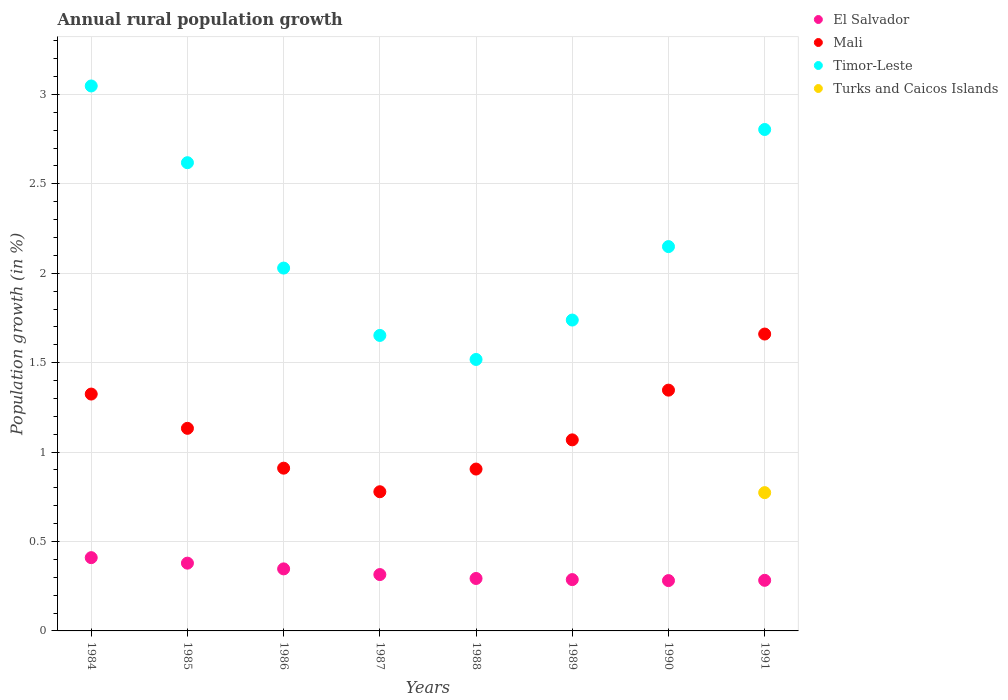Is the number of dotlines equal to the number of legend labels?
Your response must be concise. No. What is the percentage of rural population growth in El Salvador in 1989?
Your answer should be compact. 0.29. Across all years, what is the maximum percentage of rural population growth in El Salvador?
Offer a very short reply. 0.41. Across all years, what is the minimum percentage of rural population growth in Timor-Leste?
Your response must be concise. 1.52. In which year was the percentage of rural population growth in Timor-Leste maximum?
Provide a short and direct response. 1984. What is the total percentage of rural population growth in El Salvador in the graph?
Offer a terse response. 2.6. What is the difference between the percentage of rural population growth in El Salvador in 1987 and that in 1990?
Offer a very short reply. 0.03. What is the difference between the percentage of rural population growth in Mali in 1985 and the percentage of rural population growth in Turks and Caicos Islands in 1986?
Your response must be concise. 1.13. What is the average percentage of rural population growth in Mali per year?
Offer a terse response. 1.14. In the year 1984, what is the difference between the percentage of rural population growth in Mali and percentage of rural population growth in Timor-Leste?
Your answer should be very brief. -1.72. In how many years, is the percentage of rural population growth in Timor-Leste greater than 0.7 %?
Offer a very short reply. 8. What is the ratio of the percentage of rural population growth in El Salvador in 1984 to that in 1987?
Provide a short and direct response. 1.3. What is the difference between the highest and the second highest percentage of rural population growth in Timor-Leste?
Ensure brevity in your answer.  0.24. What is the difference between the highest and the lowest percentage of rural population growth in Turks and Caicos Islands?
Your response must be concise. 0.77. Is it the case that in every year, the sum of the percentage of rural population growth in Mali and percentage of rural population growth in Timor-Leste  is greater than the sum of percentage of rural population growth in El Salvador and percentage of rural population growth in Turks and Caicos Islands?
Provide a short and direct response. No. Is the percentage of rural population growth in Timor-Leste strictly greater than the percentage of rural population growth in Mali over the years?
Ensure brevity in your answer.  Yes. Is the percentage of rural population growth in Turks and Caicos Islands strictly less than the percentage of rural population growth in Mali over the years?
Your response must be concise. Yes. How many years are there in the graph?
Offer a terse response. 8. How many legend labels are there?
Ensure brevity in your answer.  4. How are the legend labels stacked?
Keep it short and to the point. Vertical. What is the title of the graph?
Your response must be concise. Annual rural population growth. What is the label or title of the Y-axis?
Keep it short and to the point. Population growth (in %). What is the Population growth (in %) in El Salvador in 1984?
Give a very brief answer. 0.41. What is the Population growth (in %) in Mali in 1984?
Offer a terse response. 1.32. What is the Population growth (in %) of Timor-Leste in 1984?
Offer a very short reply. 3.05. What is the Population growth (in %) in El Salvador in 1985?
Provide a short and direct response. 0.38. What is the Population growth (in %) in Mali in 1985?
Give a very brief answer. 1.13. What is the Population growth (in %) in Timor-Leste in 1985?
Give a very brief answer. 2.62. What is the Population growth (in %) of Turks and Caicos Islands in 1985?
Your response must be concise. 0. What is the Population growth (in %) in El Salvador in 1986?
Keep it short and to the point. 0.35. What is the Population growth (in %) in Mali in 1986?
Keep it short and to the point. 0.91. What is the Population growth (in %) of Timor-Leste in 1986?
Ensure brevity in your answer.  2.03. What is the Population growth (in %) of Turks and Caicos Islands in 1986?
Your response must be concise. 0. What is the Population growth (in %) of El Salvador in 1987?
Your answer should be compact. 0.32. What is the Population growth (in %) of Mali in 1987?
Make the answer very short. 0.78. What is the Population growth (in %) in Timor-Leste in 1987?
Offer a very short reply. 1.65. What is the Population growth (in %) in Turks and Caicos Islands in 1987?
Your response must be concise. 0. What is the Population growth (in %) of El Salvador in 1988?
Make the answer very short. 0.29. What is the Population growth (in %) in Mali in 1988?
Ensure brevity in your answer.  0.91. What is the Population growth (in %) of Timor-Leste in 1988?
Your answer should be compact. 1.52. What is the Population growth (in %) in El Salvador in 1989?
Keep it short and to the point. 0.29. What is the Population growth (in %) of Mali in 1989?
Make the answer very short. 1.07. What is the Population growth (in %) in Timor-Leste in 1989?
Make the answer very short. 1.74. What is the Population growth (in %) of El Salvador in 1990?
Your response must be concise. 0.28. What is the Population growth (in %) in Mali in 1990?
Your answer should be compact. 1.35. What is the Population growth (in %) of Timor-Leste in 1990?
Provide a short and direct response. 2.15. What is the Population growth (in %) of Turks and Caicos Islands in 1990?
Your answer should be very brief. 0. What is the Population growth (in %) in El Salvador in 1991?
Keep it short and to the point. 0.28. What is the Population growth (in %) in Mali in 1991?
Provide a short and direct response. 1.66. What is the Population growth (in %) of Timor-Leste in 1991?
Provide a succinct answer. 2.8. What is the Population growth (in %) in Turks and Caicos Islands in 1991?
Ensure brevity in your answer.  0.77. Across all years, what is the maximum Population growth (in %) in El Salvador?
Provide a succinct answer. 0.41. Across all years, what is the maximum Population growth (in %) of Mali?
Provide a succinct answer. 1.66. Across all years, what is the maximum Population growth (in %) in Timor-Leste?
Ensure brevity in your answer.  3.05. Across all years, what is the maximum Population growth (in %) of Turks and Caicos Islands?
Ensure brevity in your answer.  0.77. Across all years, what is the minimum Population growth (in %) in El Salvador?
Offer a very short reply. 0.28. Across all years, what is the minimum Population growth (in %) in Mali?
Make the answer very short. 0.78. Across all years, what is the minimum Population growth (in %) of Timor-Leste?
Make the answer very short. 1.52. Across all years, what is the minimum Population growth (in %) in Turks and Caicos Islands?
Your response must be concise. 0. What is the total Population growth (in %) in El Salvador in the graph?
Provide a succinct answer. 2.6. What is the total Population growth (in %) of Mali in the graph?
Your answer should be very brief. 9.13. What is the total Population growth (in %) of Timor-Leste in the graph?
Provide a short and direct response. 17.56. What is the total Population growth (in %) of Turks and Caicos Islands in the graph?
Offer a very short reply. 0.77. What is the difference between the Population growth (in %) in El Salvador in 1984 and that in 1985?
Offer a very short reply. 0.03. What is the difference between the Population growth (in %) of Mali in 1984 and that in 1985?
Give a very brief answer. 0.19. What is the difference between the Population growth (in %) in Timor-Leste in 1984 and that in 1985?
Make the answer very short. 0.43. What is the difference between the Population growth (in %) in El Salvador in 1984 and that in 1986?
Your answer should be very brief. 0.06. What is the difference between the Population growth (in %) in Mali in 1984 and that in 1986?
Provide a succinct answer. 0.41. What is the difference between the Population growth (in %) of Timor-Leste in 1984 and that in 1986?
Give a very brief answer. 1.02. What is the difference between the Population growth (in %) in El Salvador in 1984 and that in 1987?
Provide a short and direct response. 0.09. What is the difference between the Population growth (in %) of Mali in 1984 and that in 1987?
Your response must be concise. 0.55. What is the difference between the Population growth (in %) of Timor-Leste in 1984 and that in 1987?
Keep it short and to the point. 1.4. What is the difference between the Population growth (in %) of El Salvador in 1984 and that in 1988?
Make the answer very short. 0.12. What is the difference between the Population growth (in %) in Mali in 1984 and that in 1988?
Your response must be concise. 0.42. What is the difference between the Population growth (in %) in Timor-Leste in 1984 and that in 1988?
Your response must be concise. 1.53. What is the difference between the Population growth (in %) in El Salvador in 1984 and that in 1989?
Ensure brevity in your answer.  0.12. What is the difference between the Population growth (in %) in Mali in 1984 and that in 1989?
Offer a very short reply. 0.26. What is the difference between the Population growth (in %) in Timor-Leste in 1984 and that in 1989?
Offer a terse response. 1.31. What is the difference between the Population growth (in %) in El Salvador in 1984 and that in 1990?
Your answer should be very brief. 0.13. What is the difference between the Population growth (in %) in Mali in 1984 and that in 1990?
Give a very brief answer. -0.02. What is the difference between the Population growth (in %) of Timor-Leste in 1984 and that in 1990?
Keep it short and to the point. 0.9. What is the difference between the Population growth (in %) of El Salvador in 1984 and that in 1991?
Provide a succinct answer. 0.13. What is the difference between the Population growth (in %) in Mali in 1984 and that in 1991?
Your response must be concise. -0.34. What is the difference between the Population growth (in %) in Timor-Leste in 1984 and that in 1991?
Provide a succinct answer. 0.24. What is the difference between the Population growth (in %) of El Salvador in 1985 and that in 1986?
Provide a succinct answer. 0.03. What is the difference between the Population growth (in %) in Mali in 1985 and that in 1986?
Ensure brevity in your answer.  0.22. What is the difference between the Population growth (in %) of Timor-Leste in 1985 and that in 1986?
Ensure brevity in your answer.  0.59. What is the difference between the Population growth (in %) in El Salvador in 1985 and that in 1987?
Ensure brevity in your answer.  0.06. What is the difference between the Population growth (in %) of Mali in 1985 and that in 1987?
Offer a terse response. 0.35. What is the difference between the Population growth (in %) in Timor-Leste in 1985 and that in 1987?
Provide a succinct answer. 0.97. What is the difference between the Population growth (in %) in El Salvador in 1985 and that in 1988?
Your response must be concise. 0.09. What is the difference between the Population growth (in %) of Mali in 1985 and that in 1988?
Ensure brevity in your answer.  0.23. What is the difference between the Population growth (in %) of Timor-Leste in 1985 and that in 1988?
Keep it short and to the point. 1.1. What is the difference between the Population growth (in %) in El Salvador in 1985 and that in 1989?
Give a very brief answer. 0.09. What is the difference between the Population growth (in %) of Mali in 1985 and that in 1989?
Offer a very short reply. 0.06. What is the difference between the Population growth (in %) in Timor-Leste in 1985 and that in 1989?
Keep it short and to the point. 0.88. What is the difference between the Population growth (in %) in El Salvador in 1985 and that in 1990?
Offer a very short reply. 0.1. What is the difference between the Population growth (in %) in Mali in 1985 and that in 1990?
Provide a short and direct response. -0.21. What is the difference between the Population growth (in %) in Timor-Leste in 1985 and that in 1990?
Offer a very short reply. 0.47. What is the difference between the Population growth (in %) of El Salvador in 1985 and that in 1991?
Ensure brevity in your answer.  0.1. What is the difference between the Population growth (in %) of Mali in 1985 and that in 1991?
Provide a short and direct response. -0.53. What is the difference between the Population growth (in %) of Timor-Leste in 1985 and that in 1991?
Offer a very short reply. -0.19. What is the difference between the Population growth (in %) of El Salvador in 1986 and that in 1987?
Your answer should be compact. 0.03. What is the difference between the Population growth (in %) of Mali in 1986 and that in 1987?
Your answer should be compact. 0.13. What is the difference between the Population growth (in %) in Timor-Leste in 1986 and that in 1987?
Your response must be concise. 0.38. What is the difference between the Population growth (in %) in El Salvador in 1986 and that in 1988?
Offer a very short reply. 0.05. What is the difference between the Population growth (in %) in Mali in 1986 and that in 1988?
Ensure brevity in your answer.  0.01. What is the difference between the Population growth (in %) in Timor-Leste in 1986 and that in 1988?
Make the answer very short. 0.51. What is the difference between the Population growth (in %) in El Salvador in 1986 and that in 1989?
Give a very brief answer. 0.06. What is the difference between the Population growth (in %) in Mali in 1986 and that in 1989?
Your answer should be compact. -0.16. What is the difference between the Population growth (in %) of Timor-Leste in 1986 and that in 1989?
Provide a succinct answer. 0.29. What is the difference between the Population growth (in %) in El Salvador in 1986 and that in 1990?
Offer a terse response. 0.07. What is the difference between the Population growth (in %) in Mali in 1986 and that in 1990?
Make the answer very short. -0.44. What is the difference between the Population growth (in %) of Timor-Leste in 1986 and that in 1990?
Make the answer very short. -0.12. What is the difference between the Population growth (in %) of El Salvador in 1986 and that in 1991?
Give a very brief answer. 0.06. What is the difference between the Population growth (in %) in Mali in 1986 and that in 1991?
Keep it short and to the point. -0.75. What is the difference between the Population growth (in %) of Timor-Leste in 1986 and that in 1991?
Give a very brief answer. -0.77. What is the difference between the Population growth (in %) in El Salvador in 1987 and that in 1988?
Offer a terse response. 0.02. What is the difference between the Population growth (in %) of Mali in 1987 and that in 1988?
Make the answer very short. -0.13. What is the difference between the Population growth (in %) in Timor-Leste in 1987 and that in 1988?
Provide a succinct answer. 0.13. What is the difference between the Population growth (in %) in El Salvador in 1987 and that in 1989?
Your answer should be compact. 0.03. What is the difference between the Population growth (in %) of Mali in 1987 and that in 1989?
Offer a very short reply. -0.29. What is the difference between the Population growth (in %) of Timor-Leste in 1987 and that in 1989?
Give a very brief answer. -0.09. What is the difference between the Population growth (in %) in El Salvador in 1987 and that in 1990?
Provide a succinct answer. 0.03. What is the difference between the Population growth (in %) of Mali in 1987 and that in 1990?
Your response must be concise. -0.57. What is the difference between the Population growth (in %) of Timor-Leste in 1987 and that in 1990?
Make the answer very short. -0.5. What is the difference between the Population growth (in %) of El Salvador in 1987 and that in 1991?
Your answer should be very brief. 0.03. What is the difference between the Population growth (in %) of Mali in 1987 and that in 1991?
Your response must be concise. -0.88. What is the difference between the Population growth (in %) in Timor-Leste in 1987 and that in 1991?
Offer a very short reply. -1.15. What is the difference between the Population growth (in %) of El Salvador in 1988 and that in 1989?
Ensure brevity in your answer.  0.01. What is the difference between the Population growth (in %) of Mali in 1988 and that in 1989?
Make the answer very short. -0.16. What is the difference between the Population growth (in %) of Timor-Leste in 1988 and that in 1989?
Your answer should be very brief. -0.22. What is the difference between the Population growth (in %) of El Salvador in 1988 and that in 1990?
Offer a very short reply. 0.01. What is the difference between the Population growth (in %) in Mali in 1988 and that in 1990?
Your answer should be very brief. -0.44. What is the difference between the Population growth (in %) in Timor-Leste in 1988 and that in 1990?
Your answer should be compact. -0.63. What is the difference between the Population growth (in %) in El Salvador in 1988 and that in 1991?
Your answer should be compact. 0.01. What is the difference between the Population growth (in %) in Mali in 1988 and that in 1991?
Give a very brief answer. -0.76. What is the difference between the Population growth (in %) of Timor-Leste in 1988 and that in 1991?
Provide a succinct answer. -1.29. What is the difference between the Population growth (in %) of El Salvador in 1989 and that in 1990?
Offer a very short reply. 0.01. What is the difference between the Population growth (in %) of Mali in 1989 and that in 1990?
Offer a very short reply. -0.28. What is the difference between the Population growth (in %) of Timor-Leste in 1989 and that in 1990?
Make the answer very short. -0.41. What is the difference between the Population growth (in %) in El Salvador in 1989 and that in 1991?
Make the answer very short. 0. What is the difference between the Population growth (in %) in Mali in 1989 and that in 1991?
Provide a short and direct response. -0.59. What is the difference between the Population growth (in %) of Timor-Leste in 1989 and that in 1991?
Provide a short and direct response. -1.07. What is the difference between the Population growth (in %) of El Salvador in 1990 and that in 1991?
Your answer should be compact. -0. What is the difference between the Population growth (in %) in Mali in 1990 and that in 1991?
Offer a very short reply. -0.31. What is the difference between the Population growth (in %) of Timor-Leste in 1990 and that in 1991?
Ensure brevity in your answer.  -0.65. What is the difference between the Population growth (in %) of El Salvador in 1984 and the Population growth (in %) of Mali in 1985?
Provide a short and direct response. -0.72. What is the difference between the Population growth (in %) of El Salvador in 1984 and the Population growth (in %) of Timor-Leste in 1985?
Give a very brief answer. -2.21. What is the difference between the Population growth (in %) of Mali in 1984 and the Population growth (in %) of Timor-Leste in 1985?
Offer a terse response. -1.29. What is the difference between the Population growth (in %) in El Salvador in 1984 and the Population growth (in %) in Mali in 1986?
Provide a short and direct response. -0.5. What is the difference between the Population growth (in %) of El Salvador in 1984 and the Population growth (in %) of Timor-Leste in 1986?
Provide a short and direct response. -1.62. What is the difference between the Population growth (in %) in Mali in 1984 and the Population growth (in %) in Timor-Leste in 1986?
Keep it short and to the point. -0.7. What is the difference between the Population growth (in %) of El Salvador in 1984 and the Population growth (in %) of Mali in 1987?
Make the answer very short. -0.37. What is the difference between the Population growth (in %) in El Salvador in 1984 and the Population growth (in %) in Timor-Leste in 1987?
Your response must be concise. -1.24. What is the difference between the Population growth (in %) in Mali in 1984 and the Population growth (in %) in Timor-Leste in 1987?
Offer a very short reply. -0.33. What is the difference between the Population growth (in %) in El Salvador in 1984 and the Population growth (in %) in Mali in 1988?
Offer a terse response. -0.5. What is the difference between the Population growth (in %) of El Salvador in 1984 and the Population growth (in %) of Timor-Leste in 1988?
Provide a succinct answer. -1.11. What is the difference between the Population growth (in %) in Mali in 1984 and the Population growth (in %) in Timor-Leste in 1988?
Keep it short and to the point. -0.19. What is the difference between the Population growth (in %) in El Salvador in 1984 and the Population growth (in %) in Mali in 1989?
Keep it short and to the point. -0.66. What is the difference between the Population growth (in %) of El Salvador in 1984 and the Population growth (in %) of Timor-Leste in 1989?
Keep it short and to the point. -1.33. What is the difference between the Population growth (in %) in Mali in 1984 and the Population growth (in %) in Timor-Leste in 1989?
Your answer should be compact. -0.41. What is the difference between the Population growth (in %) in El Salvador in 1984 and the Population growth (in %) in Mali in 1990?
Offer a very short reply. -0.94. What is the difference between the Population growth (in %) in El Salvador in 1984 and the Population growth (in %) in Timor-Leste in 1990?
Provide a short and direct response. -1.74. What is the difference between the Population growth (in %) in Mali in 1984 and the Population growth (in %) in Timor-Leste in 1990?
Offer a very short reply. -0.82. What is the difference between the Population growth (in %) of El Salvador in 1984 and the Population growth (in %) of Mali in 1991?
Offer a terse response. -1.25. What is the difference between the Population growth (in %) in El Salvador in 1984 and the Population growth (in %) in Timor-Leste in 1991?
Give a very brief answer. -2.39. What is the difference between the Population growth (in %) in El Salvador in 1984 and the Population growth (in %) in Turks and Caicos Islands in 1991?
Your answer should be compact. -0.36. What is the difference between the Population growth (in %) of Mali in 1984 and the Population growth (in %) of Timor-Leste in 1991?
Make the answer very short. -1.48. What is the difference between the Population growth (in %) of Mali in 1984 and the Population growth (in %) of Turks and Caicos Islands in 1991?
Offer a very short reply. 0.55. What is the difference between the Population growth (in %) of Timor-Leste in 1984 and the Population growth (in %) of Turks and Caicos Islands in 1991?
Ensure brevity in your answer.  2.27. What is the difference between the Population growth (in %) in El Salvador in 1985 and the Population growth (in %) in Mali in 1986?
Give a very brief answer. -0.53. What is the difference between the Population growth (in %) in El Salvador in 1985 and the Population growth (in %) in Timor-Leste in 1986?
Provide a succinct answer. -1.65. What is the difference between the Population growth (in %) of Mali in 1985 and the Population growth (in %) of Timor-Leste in 1986?
Keep it short and to the point. -0.9. What is the difference between the Population growth (in %) of El Salvador in 1985 and the Population growth (in %) of Mali in 1987?
Your answer should be very brief. -0.4. What is the difference between the Population growth (in %) in El Salvador in 1985 and the Population growth (in %) in Timor-Leste in 1987?
Your answer should be compact. -1.27. What is the difference between the Population growth (in %) in Mali in 1985 and the Population growth (in %) in Timor-Leste in 1987?
Offer a terse response. -0.52. What is the difference between the Population growth (in %) in El Salvador in 1985 and the Population growth (in %) in Mali in 1988?
Keep it short and to the point. -0.53. What is the difference between the Population growth (in %) in El Salvador in 1985 and the Population growth (in %) in Timor-Leste in 1988?
Keep it short and to the point. -1.14. What is the difference between the Population growth (in %) in Mali in 1985 and the Population growth (in %) in Timor-Leste in 1988?
Offer a very short reply. -0.39. What is the difference between the Population growth (in %) in El Salvador in 1985 and the Population growth (in %) in Mali in 1989?
Provide a short and direct response. -0.69. What is the difference between the Population growth (in %) in El Salvador in 1985 and the Population growth (in %) in Timor-Leste in 1989?
Offer a very short reply. -1.36. What is the difference between the Population growth (in %) of Mali in 1985 and the Population growth (in %) of Timor-Leste in 1989?
Make the answer very short. -0.61. What is the difference between the Population growth (in %) in El Salvador in 1985 and the Population growth (in %) in Mali in 1990?
Make the answer very short. -0.97. What is the difference between the Population growth (in %) of El Salvador in 1985 and the Population growth (in %) of Timor-Leste in 1990?
Provide a succinct answer. -1.77. What is the difference between the Population growth (in %) of Mali in 1985 and the Population growth (in %) of Timor-Leste in 1990?
Keep it short and to the point. -1.02. What is the difference between the Population growth (in %) of El Salvador in 1985 and the Population growth (in %) of Mali in 1991?
Provide a succinct answer. -1.28. What is the difference between the Population growth (in %) in El Salvador in 1985 and the Population growth (in %) in Timor-Leste in 1991?
Your response must be concise. -2.42. What is the difference between the Population growth (in %) in El Salvador in 1985 and the Population growth (in %) in Turks and Caicos Islands in 1991?
Give a very brief answer. -0.39. What is the difference between the Population growth (in %) of Mali in 1985 and the Population growth (in %) of Timor-Leste in 1991?
Provide a succinct answer. -1.67. What is the difference between the Population growth (in %) in Mali in 1985 and the Population growth (in %) in Turks and Caicos Islands in 1991?
Give a very brief answer. 0.36. What is the difference between the Population growth (in %) in Timor-Leste in 1985 and the Population growth (in %) in Turks and Caicos Islands in 1991?
Your response must be concise. 1.84. What is the difference between the Population growth (in %) of El Salvador in 1986 and the Population growth (in %) of Mali in 1987?
Ensure brevity in your answer.  -0.43. What is the difference between the Population growth (in %) in El Salvador in 1986 and the Population growth (in %) in Timor-Leste in 1987?
Ensure brevity in your answer.  -1.31. What is the difference between the Population growth (in %) in Mali in 1986 and the Population growth (in %) in Timor-Leste in 1987?
Your response must be concise. -0.74. What is the difference between the Population growth (in %) of El Salvador in 1986 and the Population growth (in %) of Mali in 1988?
Keep it short and to the point. -0.56. What is the difference between the Population growth (in %) in El Salvador in 1986 and the Population growth (in %) in Timor-Leste in 1988?
Your answer should be very brief. -1.17. What is the difference between the Population growth (in %) of Mali in 1986 and the Population growth (in %) of Timor-Leste in 1988?
Provide a succinct answer. -0.61. What is the difference between the Population growth (in %) in El Salvador in 1986 and the Population growth (in %) in Mali in 1989?
Your answer should be very brief. -0.72. What is the difference between the Population growth (in %) in El Salvador in 1986 and the Population growth (in %) in Timor-Leste in 1989?
Offer a terse response. -1.39. What is the difference between the Population growth (in %) of Mali in 1986 and the Population growth (in %) of Timor-Leste in 1989?
Your answer should be very brief. -0.83. What is the difference between the Population growth (in %) in El Salvador in 1986 and the Population growth (in %) in Mali in 1990?
Your response must be concise. -1. What is the difference between the Population growth (in %) in El Salvador in 1986 and the Population growth (in %) in Timor-Leste in 1990?
Your answer should be compact. -1.8. What is the difference between the Population growth (in %) in Mali in 1986 and the Population growth (in %) in Timor-Leste in 1990?
Offer a terse response. -1.24. What is the difference between the Population growth (in %) of El Salvador in 1986 and the Population growth (in %) of Mali in 1991?
Keep it short and to the point. -1.31. What is the difference between the Population growth (in %) of El Salvador in 1986 and the Population growth (in %) of Timor-Leste in 1991?
Give a very brief answer. -2.46. What is the difference between the Population growth (in %) of El Salvador in 1986 and the Population growth (in %) of Turks and Caicos Islands in 1991?
Make the answer very short. -0.43. What is the difference between the Population growth (in %) of Mali in 1986 and the Population growth (in %) of Timor-Leste in 1991?
Keep it short and to the point. -1.89. What is the difference between the Population growth (in %) in Mali in 1986 and the Population growth (in %) in Turks and Caicos Islands in 1991?
Ensure brevity in your answer.  0.14. What is the difference between the Population growth (in %) in Timor-Leste in 1986 and the Population growth (in %) in Turks and Caicos Islands in 1991?
Offer a very short reply. 1.26. What is the difference between the Population growth (in %) in El Salvador in 1987 and the Population growth (in %) in Mali in 1988?
Keep it short and to the point. -0.59. What is the difference between the Population growth (in %) in El Salvador in 1987 and the Population growth (in %) in Timor-Leste in 1988?
Provide a succinct answer. -1.2. What is the difference between the Population growth (in %) in Mali in 1987 and the Population growth (in %) in Timor-Leste in 1988?
Your response must be concise. -0.74. What is the difference between the Population growth (in %) of El Salvador in 1987 and the Population growth (in %) of Mali in 1989?
Give a very brief answer. -0.75. What is the difference between the Population growth (in %) of El Salvador in 1987 and the Population growth (in %) of Timor-Leste in 1989?
Give a very brief answer. -1.42. What is the difference between the Population growth (in %) in Mali in 1987 and the Population growth (in %) in Timor-Leste in 1989?
Your response must be concise. -0.96. What is the difference between the Population growth (in %) in El Salvador in 1987 and the Population growth (in %) in Mali in 1990?
Provide a short and direct response. -1.03. What is the difference between the Population growth (in %) in El Salvador in 1987 and the Population growth (in %) in Timor-Leste in 1990?
Your response must be concise. -1.83. What is the difference between the Population growth (in %) in Mali in 1987 and the Population growth (in %) in Timor-Leste in 1990?
Your response must be concise. -1.37. What is the difference between the Population growth (in %) of El Salvador in 1987 and the Population growth (in %) of Mali in 1991?
Offer a terse response. -1.34. What is the difference between the Population growth (in %) of El Salvador in 1987 and the Population growth (in %) of Timor-Leste in 1991?
Offer a terse response. -2.49. What is the difference between the Population growth (in %) of El Salvador in 1987 and the Population growth (in %) of Turks and Caicos Islands in 1991?
Your answer should be very brief. -0.46. What is the difference between the Population growth (in %) of Mali in 1987 and the Population growth (in %) of Timor-Leste in 1991?
Keep it short and to the point. -2.03. What is the difference between the Population growth (in %) of Mali in 1987 and the Population growth (in %) of Turks and Caicos Islands in 1991?
Offer a very short reply. 0.01. What is the difference between the Population growth (in %) in Timor-Leste in 1987 and the Population growth (in %) in Turks and Caicos Islands in 1991?
Offer a very short reply. 0.88. What is the difference between the Population growth (in %) in El Salvador in 1988 and the Population growth (in %) in Mali in 1989?
Offer a terse response. -0.78. What is the difference between the Population growth (in %) in El Salvador in 1988 and the Population growth (in %) in Timor-Leste in 1989?
Give a very brief answer. -1.45. What is the difference between the Population growth (in %) in Mali in 1988 and the Population growth (in %) in Timor-Leste in 1989?
Provide a short and direct response. -0.83. What is the difference between the Population growth (in %) of El Salvador in 1988 and the Population growth (in %) of Mali in 1990?
Make the answer very short. -1.05. What is the difference between the Population growth (in %) of El Salvador in 1988 and the Population growth (in %) of Timor-Leste in 1990?
Give a very brief answer. -1.86. What is the difference between the Population growth (in %) of Mali in 1988 and the Population growth (in %) of Timor-Leste in 1990?
Your answer should be compact. -1.24. What is the difference between the Population growth (in %) of El Salvador in 1988 and the Population growth (in %) of Mali in 1991?
Your response must be concise. -1.37. What is the difference between the Population growth (in %) of El Salvador in 1988 and the Population growth (in %) of Timor-Leste in 1991?
Your answer should be compact. -2.51. What is the difference between the Population growth (in %) of El Salvador in 1988 and the Population growth (in %) of Turks and Caicos Islands in 1991?
Make the answer very short. -0.48. What is the difference between the Population growth (in %) in Mali in 1988 and the Population growth (in %) in Timor-Leste in 1991?
Make the answer very short. -1.9. What is the difference between the Population growth (in %) of Mali in 1988 and the Population growth (in %) of Turks and Caicos Islands in 1991?
Ensure brevity in your answer.  0.13. What is the difference between the Population growth (in %) in Timor-Leste in 1988 and the Population growth (in %) in Turks and Caicos Islands in 1991?
Ensure brevity in your answer.  0.74. What is the difference between the Population growth (in %) of El Salvador in 1989 and the Population growth (in %) of Mali in 1990?
Your response must be concise. -1.06. What is the difference between the Population growth (in %) of El Salvador in 1989 and the Population growth (in %) of Timor-Leste in 1990?
Offer a very short reply. -1.86. What is the difference between the Population growth (in %) in Mali in 1989 and the Population growth (in %) in Timor-Leste in 1990?
Give a very brief answer. -1.08. What is the difference between the Population growth (in %) of El Salvador in 1989 and the Population growth (in %) of Mali in 1991?
Your answer should be very brief. -1.37. What is the difference between the Population growth (in %) of El Salvador in 1989 and the Population growth (in %) of Timor-Leste in 1991?
Provide a short and direct response. -2.52. What is the difference between the Population growth (in %) in El Salvador in 1989 and the Population growth (in %) in Turks and Caicos Islands in 1991?
Keep it short and to the point. -0.49. What is the difference between the Population growth (in %) in Mali in 1989 and the Population growth (in %) in Timor-Leste in 1991?
Keep it short and to the point. -1.74. What is the difference between the Population growth (in %) of Mali in 1989 and the Population growth (in %) of Turks and Caicos Islands in 1991?
Keep it short and to the point. 0.3. What is the difference between the Population growth (in %) of Timor-Leste in 1989 and the Population growth (in %) of Turks and Caicos Islands in 1991?
Ensure brevity in your answer.  0.97. What is the difference between the Population growth (in %) in El Salvador in 1990 and the Population growth (in %) in Mali in 1991?
Keep it short and to the point. -1.38. What is the difference between the Population growth (in %) of El Salvador in 1990 and the Population growth (in %) of Timor-Leste in 1991?
Offer a terse response. -2.52. What is the difference between the Population growth (in %) of El Salvador in 1990 and the Population growth (in %) of Turks and Caicos Islands in 1991?
Make the answer very short. -0.49. What is the difference between the Population growth (in %) of Mali in 1990 and the Population growth (in %) of Timor-Leste in 1991?
Ensure brevity in your answer.  -1.46. What is the difference between the Population growth (in %) of Mali in 1990 and the Population growth (in %) of Turks and Caicos Islands in 1991?
Ensure brevity in your answer.  0.57. What is the difference between the Population growth (in %) of Timor-Leste in 1990 and the Population growth (in %) of Turks and Caicos Islands in 1991?
Make the answer very short. 1.38. What is the average Population growth (in %) in El Salvador per year?
Make the answer very short. 0.32. What is the average Population growth (in %) in Mali per year?
Make the answer very short. 1.14. What is the average Population growth (in %) in Timor-Leste per year?
Provide a succinct answer. 2.19. What is the average Population growth (in %) in Turks and Caicos Islands per year?
Ensure brevity in your answer.  0.1. In the year 1984, what is the difference between the Population growth (in %) of El Salvador and Population growth (in %) of Mali?
Your answer should be compact. -0.91. In the year 1984, what is the difference between the Population growth (in %) in El Salvador and Population growth (in %) in Timor-Leste?
Provide a short and direct response. -2.64. In the year 1984, what is the difference between the Population growth (in %) of Mali and Population growth (in %) of Timor-Leste?
Give a very brief answer. -1.72. In the year 1985, what is the difference between the Population growth (in %) of El Salvador and Population growth (in %) of Mali?
Make the answer very short. -0.75. In the year 1985, what is the difference between the Population growth (in %) of El Salvador and Population growth (in %) of Timor-Leste?
Give a very brief answer. -2.24. In the year 1985, what is the difference between the Population growth (in %) in Mali and Population growth (in %) in Timor-Leste?
Give a very brief answer. -1.49. In the year 1986, what is the difference between the Population growth (in %) in El Salvador and Population growth (in %) in Mali?
Give a very brief answer. -0.56. In the year 1986, what is the difference between the Population growth (in %) in El Salvador and Population growth (in %) in Timor-Leste?
Make the answer very short. -1.68. In the year 1986, what is the difference between the Population growth (in %) of Mali and Population growth (in %) of Timor-Leste?
Keep it short and to the point. -1.12. In the year 1987, what is the difference between the Population growth (in %) in El Salvador and Population growth (in %) in Mali?
Make the answer very short. -0.46. In the year 1987, what is the difference between the Population growth (in %) in El Salvador and Population growth (in %) in Timor-Leste?
Make the answer very short. -1.34. In the year 1987, what is the difference between the Population growth (in %) of Mali and Population growth (in %) of Timor-Leste?
Give a very brief answer. -0.87. In the year 1988, what is the difference between the Population growth (in %) of El Salvador and Population growth (in %) of Mali?
Provide a succinct answer. -0.61. In the year 1988, what is the difference between the Population growth (in %) of El Salvador and Population growth (in %) of Timor-Leste?
Offer a very short reply. -1.22. In the year 1988, what is the difference between the Population growth (in %) in Mali and Population growth (in %) in Timor-Leste?
Offer a terse response. -0.61. In the year 1989, what is the difference between the Population growth (in %) of El Salvador and Population growth (in %) of Mali?
Provide a succinct answer. -0.78. In the year 1989, what is the difference between the Population growth (in %) of El Salvador and Population growth (in %) of Timor-Leste?
Your answer should be very brief. -1.45. In the year 1989, what is the difference between the Population growth (in %) of Mali and Population growth (in %) of Timor-Leste?
Keep it short and to the point. -0.67. In the year 1990, what is the difference between the Population growth (in %) of El Salvador and Population growth (in %) of Mali?
Give a very brief answer. -1.06. In the year 1990, what is the difference between the Population growth (in %) in El Salvador and Population growth (in %) in Timor-Leste?
Provide a succinct answer. -1.87. In the year 1990, what is the difference between the Population growth (in %) in Mali and Population growth (in %) in Timor-Leste?
Provide a short and direct response. -0.8. In the year 1991, what is the difference between the Population growth (in %) of El Salvador and Population growth (in %) of Mali?
Make the answer very short. -1.38. In the year 1991, what is the difference between the Population growth (in %) of El Salvador and Population growth (in %) of Timor-Leste?
Offer a terse response. -2.52. In the year 1991, what is the difference between the Population growth (in %) in El Salvador and Population growth (in %) in Turks and Caicos Islands?
Offer a very short reply. -0.49. In the year 1991, what is the difference between the Population growth (in %) of Mali and Population growth (in %) of Timor-Leste?
Provide a succinct answer. -1.14. In the year 1991, what is the difference between the Population growth (in %) of Mali and Population growth (in %) of Turks and Caicos Islands?
Your answer should be very brief. 0.89. In the year 1991, what is the difference between the Population growth (in %) in Timor-Leste and Population growth (in %) in Turks and Caicos Islands?
Offer a very short reply. 2.03. What is the ratio of the Population growth (in %) of El Salvador in 1984 to that in 1985?
Give a very brief answer. 1.08. What is the ratio of the Population growth (in %) of Mali in 1984 to that in 1985?
Give a very brief answer. 1.17. What is the ratio of the Population growth (in %) of Timor-Leste in 1984 to that in 1985?
Offer a very short reply. 1.16. What is the ratio of the Population growth (in %) of El Salvador in 1984 to that in 1986?
Provide a succinct answer. 1.18. What is the ratio of the Population growth (in %) of Mali in 1984 to that in 1986?
Give a very brief answer. 1.46. What is the ratio of the Population growth (in %) of Timor-Leste in 1984 to that in 1986?
Give a very brief answer. 1.5. What is the ratio of the Population growth (in %) in Mali in 1984 to that in 1987?
Provide a succinct answer. 1.7. What is the ratio of the Population growth (in %) in Timor-Leste in 1984 to that in 1987?
Give a very brief answer. 1.84. What is the ratio of the Population growth (in %) of El Salvador in 1984 to that in 1988?
Ensure brevity in your answer.  1.4. What is the ratio of the Population growth (in %) of Mali in 1984 to that in 1988?
Ensure brevity in your answer.  1.46. What is the ratio of the Population growth (in %) in Timor-Leste in 1984 to that in 1988?
Ensure brevity in your answer.  2.01. What is the ratio of the Population growth (in %) in El Salvador in 1984 to that in 1989?
Give a very brief answer. 1.43. What is the ratio of the Population growth (in %) in Mali in 1984 to that in 1989?
Your answer should be very brief. 1.24. What is the ratio of the Population growth (in %) of Timor-Leste in 1984 to that in 1989?
Offer a very short reply. 1.75. What is the ratio of the Population growth (in %) of El Salvador in 1984 to that in 1990?
Your response must be concise. 1.46. What is the ratio of the Population growth (in %) in Mali in 1984 to that in 1990?
Your answer should be compact. 0.98. What is the ratio of the Population growth (in %) of Timor-Leste in 1984 to that in 1990?
Provide a succinct answer. 1.42. What is the ratio of the Population growth (in %) in El Salvador in 1984 to that in 1991?
Provide a succinct answer. 1.45. What is the ratio of the Population growth (in %) in Mali in 1984 to that in 1991?
Offer a very short reply. 0.8. What is the ratio of the Population growth (in %) of Timor-Leste in 1984 to that in 1991?
Your answer should be very brief. 1.09. What is the ratio of the Population growth (in %) in El Salvador in 1985 to that in 1986?
Your response must be concise. 1.09. What is the ratio of the Population growth (in %) in Mali in 1985 to that in 1986?
Your answer should be compact. 1.24. What is the ratio of the Population growth (in %) of Timor-Leste in 1985 to that in 1986?
Provide a short and direct response. 1.29. What is the ratio of the Population growth (in %) of El Salvador in 1985 to that in 1987?
Make the answer very short. 1.2. What is the ratio of the Population growth (in %) of Mali in 1985 to that in 1987?
Provide a succinct answer. 1.46. What is the ratio of the Population growth (in %) in Timor-Leste in 1985 to that in 1987?
Give a very brief answer. 1.58. What is the ratio of the Population growth (in %) in El Salvador in 1985 to that in 1988?
Provide a short and direct response. 1.29. What is the ratio of the Population growth (in %) of Mali in 1985 to that in 1988?
Your answer should be very brief. 1.25. What is the ratio of the Population growth (in %) in Timor-Leste in 1985 to that in 1988?
Provide a short and direct response. 1.72. What is the ratio of the Population growth (in %) of El Salvador in 1985 to that in 1989?
Give a very brief answer. 1.32. What is the ratio of the Population growth (in %) in Mali in 1985 to that in 1989?
Your answer should be compact. 1.06. What is the ratio of the Population growth (in %) of Timor-Leste in 1985 to that in 1989?
Offer a very short reply. 1.51. What is the ratio of the Population growth (in %) of El Salvador in 1985 to that in 1990?
Keep it short and to the point. 1.35. What is the ratio of the Population growth (in %) in Mali in 1985 to that in 1990?
Make the answer very short. 0.84. What is the ratio of the Population growth (in %) of Timor-Leste in 1985 to that in 1990?
Keep it short and to the point. 1.22. What is the ratio of the Population growth (in %) in El Salvador in 1985 to that in 1991?
Provide a succinct answer. 1.34. What is the ratio of the Population growth (in %) of Mali in 1985 to that in 1991?
Provide a succinct answer. 0.68. What is the ratio of the Population growth (in %) of Timor-Leste in 1985 to that in 1991?
Your answer should be compact. 0.93. What is the ratio of the Population growth (in %) in El Salvador in 1986 to that in 1987?
Ensure brevity in your answer.  1.1. What is the ratio of the Population growth (in %) of Mali in 1986 to that in 1987?
Your answer should be very brief. 1.17. What is the ratio of the Population growth (in %) of Timor-Leste in 1986 to that in 1987?
Keep it short and to the point. 1.23. What is the ratio of the Population growth (in %) in El Salvador in 1986 to that in 1988?
Your answer should be very brief. 1.18. What is the ratio of the Population growth (in %) in Timor-Leste in 1986 to that in 1988?
Ensure brevity in your answer.  1.34. What is the ratio of the Population growth (in %) in El Salvador in 1986 to that in 1989?
Your response must be concise. 1.21. What is the ratio of the Population growth (in %) of Mali in 1986 to that in 1989?
Your answer should be very brief. 0.85. What is the ratio of the Population growth (in %) in Timor-Leste in 1986 to that in 1989?
Your answer should be very brief. 1.17. What is the ratio of the Population growth (in %) of El Salvador in 1986 to that in 1990?
Give a very brief answer. 1.23. What is the ratio of the Population growth (in %) of Mali in 1986 to that in 1990?
Your answer should be very brief. 0.68. What is the ratio of the Population growth (in %) in Timor-Leste in 1986 to that in 1990?
Your answer should be compact. 0.94. What is the ratio of the Population growth (in %) of El Salvador in 1986 to that in 1991?
Your answer should be very brief. 1.23. What is the ratio of the Population growth (in %) of Mali in 1986 to that in 1991?
Your answer should be compact. 0.55. What is the ratio of the Population growth (in %) of Timor-Leste in 1986 to that in 1991?
Offer a very short reply. 0.72. What is the ratio of the Population growth (in %) in El Salvador in 1987 to that in 1988?
Your answer should be compact. 1.07. What is the ratio of the Population growth (in %) of Mali in 1987 to that in 1988?
Give a very brief answer. 0.86. What is the ratio of the Population growth (in %) of Timor-Leste in 1987 to that in 1988?
Keep it short and to the point. 1.09. What is the ratio of the Population growth (in %) of El Salvador in 1987 to that in 1989?
Give a very brief answer. 1.1. What is the ratio of the Population growth (in %) of Mali in 1987 to that in 1989?
Give a very brief answer. 0.73. What is the ratio of the Population growth (in %) of Timor-Leste in 1987 to that in 1989?
Offer a very short reply. 0.95. What is the ratio of the Population growth (in %) in El Salvador in 1987 to that in 1990?
Your response must be concise. 1.12. What is the ratio of the Population growth (in %) of Mali in 1987 to that in 1990?
Your answer should be compact. 0.58. What is the ratio of the Population growth (in %) of Timor-Leste in 1987 to that in 1990?
Your answer should be compact. 0.77. What is the ratio of the Population growth (in %) of El Salvador in 1987 to that in 1991?
Make the answer very short. 1.11. What is the ratio of the Population growth (in %) of Mali in 1987 to that in 1991?
Offer a terse response. 0.47. What is the ratio of the Population growth (in %) of Timor-Leste in 1987 to that in 1991?
Keep it short and to the point. 0.59. What is the ratio of the Population growth (in %) of El Salvador in 1988 to that in 1989?
Ensure brevity in your answer.  1.02. What is the ratio of the Population growth (in %) in Mali in 1988 to that in 1989?
Provide a short and direct response. 0.85. What is the ratio of the Population growth (in %) in Timor-Leste in 1988 to that in 1989?
Provide a short and direct response. 0.87. What is the ratio of the Population growth (in %) in El Salvador in 1988 to that in 1990?
Your answer should be very brief. 1.04. What is the ratio of the Population growth (in %) in Mali in 1988 to that in 1990?
Offer a very short reply. 0.67. What is the ratio of the Population growth (in %) of Timor-Leste in 1988 to that in 1990?
Offer a very short reply. 0.71. What is the ratio of the Population growth (in %) in El Salvador in 1988 to that in 1991?
Your answer should be compact. 1.04. What is the ratio of the Population growth (in %) in Mali in 1988 to that in 1991?
Offer a very short reply. 0.55. What is the ratio of the Population growth (in %) of Timor-Leste in 1988 to that in 1991?
Ensure brevity in your answer.  0.54. What is the ratio of the Population growth (in %) of El Salvador in 1989 to that in 1990?
Your answer should be very brief. 1.02. What is the ratio of the Population growth (in %) of Mali in 1989 to that in 1990?
Offer a terse response. 0.79. What is the ratio of the Population growth (in %) of Timor-Leste in 1989 to that in 1990?
Your answer should be very brief. 0.81. What is the ratio of the Population growth (in %) in El Salvador in 1989 to that in 1991?
Provide a succinct answer. 1.01. What is the ratio of the Population growth (in %) in Mali in 1989 to that in 1991?
Your answer should be compact. 0.64. What is the ratio of the Population growth (in %) of Timor-Leste in 1989 to that in 1991?
Provide a succinct answer. 0.62. What is the ratio of the Population growth (in %) of Mali in 1990 to that in 1991?
Give a very brief answer. 0.81. What is the ratio of the Population growth (in %) of Timor-Leste in 1990 to that in 1991?
Give a very brief answer. 0.77. What is the difference between the highest and the second highest Population growth (in %) in El Salvador?
Your response must be concise. 0.03. What is the difference between the highest and the second highest Population growth (in %) in Mali?
Offer a very short reply. 0.31. What is the difference between the highest and the second highest Population growth (in %) in Timor-Leste?
Ensure brevity in your answer.  0.24. What is the difference between the highest and the lowest Population growth (in %) of El Salvador?
Offer a very short reply. 0.13. What is the difference between the highest and the lowest Population growth (in %) of Mali?
Your answer should be very brief. 0.88. What is the difference between the highest and the lowest Population growth (in %) in Timor-Leste?
Keep it short and to the point. 1.53. What is the difference between the highest and the lowest Population growth (in %) of Turks and Caicos Islands?
Offer a terse response. 0.77. 